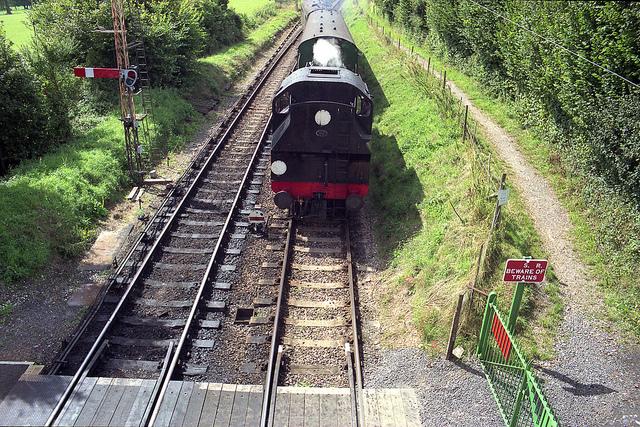Is it cold out?
Keep it brief. No. What does the sign say?
Quick response, please. Beware of trains. How many people on the path?
Answer briefly. 0. 